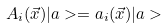<formula> <loc_0><loc_0><loc_500><loc_500>A _ { i } ( \vec { x } ) | a > = a _ { i } ( \vec { x } ) | a ></formula> 